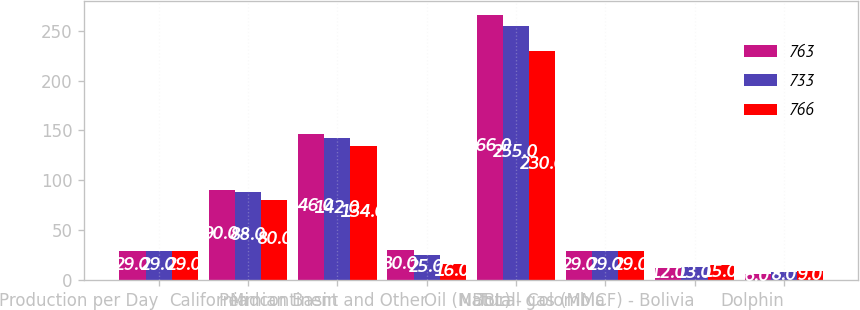Convert chart. <chart><loc_0><loc_0><loc_500><loc_500><stacked_bar_chart><ecel><fcel>Production per Day<fcel>California<fcel>Permian Basin<fcel>Midcontinent and Other<fcel>Total<fcel>Oil (MBBL) - Colombia<fcel>Natural gas (MMCF) - Bolivia<fcel>Dolphin<nl><fcel>763<fcel>29<fcel>90<fcel>146<fcel>30<fcel>266<fcel>29<fcel>12<fcel>6<nl><fcel>733<fcel>29<fcel>88<fcel>142<fcel>25<fcel>255<fcel>29<fcel>13<fcel>8<nl><fcel>766<fcel>29<fcel>80<fcel>134<fcel>16<fcel>230<fcel>29<fcel>15<fcel>9<nl></chart> 